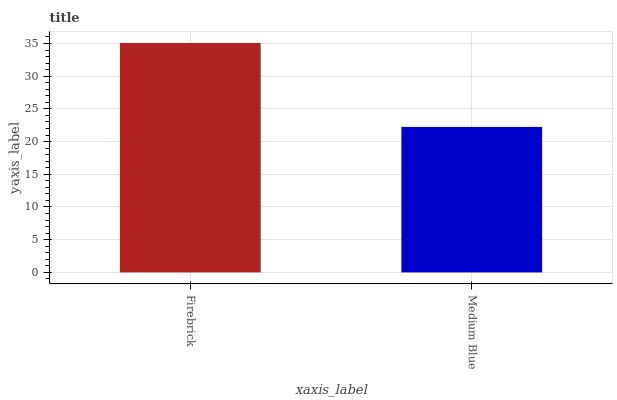Is Medium Blue the minimum?
Answer yes or no. Yes. Is Firebrick the maximum?
Answer yes or no. Yes. Is Medium Blue the maximum?
Answer yes or no. No. Is Firebrick greater than Medium Blue?
Answer yes or no. Yes. Is Medium Blue less than Firebrick?
Answer yes or no. Yes. Is Medium Blue greater than Firebrick?
Answer yes or no. No. Is Firebrick less than Medium Blue?
Answer yes or no. No. Is Firebrick the high median?
Answer yes or no. Yes. Is Medium Blue the low median?
Answer yes or no. Yes. Is Medium Blue the high median?
Answer yes or no. No. Is Firebrick the low median?
Answer yes or no. No. 